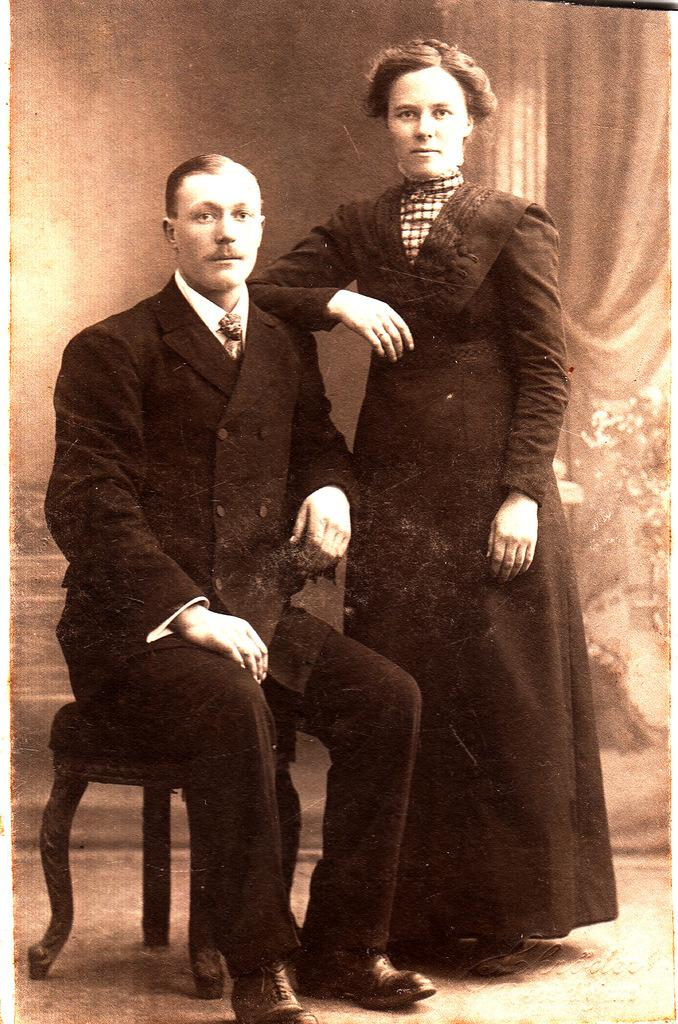Who is present in the image? There is a man and a lady in the image. What is the man doing in the image? The man is sitting on a table. How is the lady positioned in relation to the man? The lady is standing beside the man. What type of silk material is draped over the man's shoulders in the image? There is no silk material present in the image. How does the steam from the man's cup of tea affect the lady's hair in the image? There is no cup of tea or steam present in the image. 